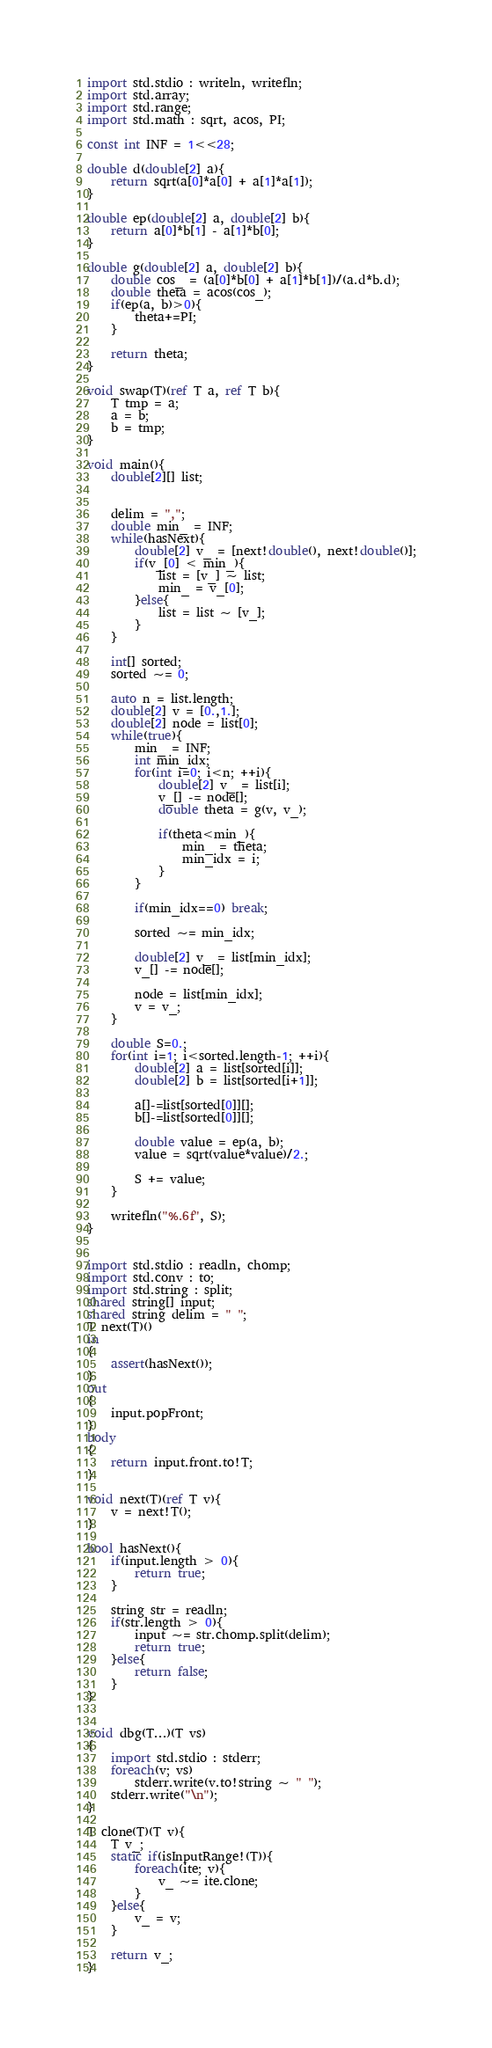Convert code to text. <code><loc_0><loc_0><loc_500><loc_500><_D_>import std.stdio : writeln, writefln;
import std.array;
import std.range;
import std.math : sqrt, acos, PI;

const int INF = 1<<28;

double d(double[2] a){
	return sqrt(a[0]*a[0] + a[1]*a[1]);
}

double ep(double[2] a, double[2] b){
	return a[0]*b[1] - a[1]*b[0];
}

double g(double[2] a, double[2] b){
	double cos_ = (a[0]*b[0] + a[1]*b[1])/(a.d*b.d);
	double theta = acos(cos_);
	if(ep(a, b)>0){
		theta+=PI;
	}
	
	return theta;
}

void swap(T)(ref T a, ref T b){
	T tmp = a;
	a = b;
	b = tmp;
}

void main(){
	double[2][] list;
	
	
	delim = ",";
	double min_ = INF;
	while(hasNext){
		double[2] v_ = [next!double(), next!double()];
		if(v_[0] < min_){
			list = [v_] ~ list;
			min_ = v_[0];
		}else{
			list = list ~ [v_];
		}
	}
	
	int[] sorted;
	sorted ~= 0;
	
	auto n = list.length;
	double[2] v = [0.,1.];
	double[2] node = list[0];
	while(true){
		min_ = INF;
		int min_idx;
		for(int i=0; i<n; ++i){
			double[2] v_ = list[i];
			v_[] -= node[];
			double theta = g(v, v_);
			
			if(theta<min_){
				min_ = theta;
				min_idx = i;
			}
		}
		
		if(min_idx==0) break;
		
		sorted ~= min_idx;
		
		double[2] v_ = list[min_idx];
		v_[] -= node[];
		
		node = list[min_idx];
		v = v_;
	}
	
	double S=0.;
	for(int i=1; i<sorted.length-1; ++i){
		double[2] a = list[sorted[i]];
		double[2] b = list[sorted[i+1]];
		
		a[]-=list[sorted[0]][];
		b[]-=list[sorted[0]][];
		
		double value = ep(a, b);
		value = sqrt(value*value)/2.;
		
		S += value;
	}
	
	writefln("%.6f", S);
}


import std.stdio : readln, chomp;
import std.conv : to;
import std.string : split;
shared string[] input;
shared string delim = " ";
T next(T)()
in
{
	assert(hasNext());
}
out
{
	input.popFront;
}
body
{
	return input.front.to!T;
}

void next(T)(ref T v){
	v = next!T();
}

bool hasNext(){
	if(input.length > 0){
		return true;
	}
	
	string str = readln;
	if(str.length > 0){
		input ~= str.chomp.split(delim);
		return true;
	}else{
		return false;
	}
}


void dbg(T...)(T vs)
{
	import std.stdio : stderr;
	foreach(v; vs)
		stderr.write(v.to!string ~ " ");
	stderr.write("\n");
}

T clone(T)(T v){
	T v_;
	static if(isInputRange!(T)){
		foreach(ite; v){
			v_ ~= ite.clone;
		}
	}else{
		v_ = v;
	}
	
	return v_;
}</code> 